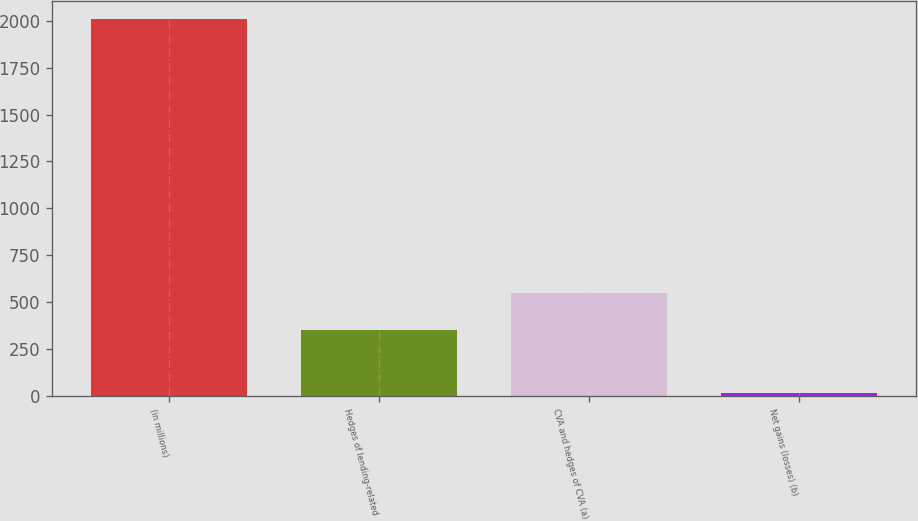Convert chart to OTSL. <chart><loc_0><loc_0><loc_500><loc_500><bar_chart><fcel>(in millions)<fcel>Hedges of lending-related<fcel>CVA and hedges of CVA (a)<fcel>Net gains (losses) (b)<nl><fcel>2007<fcel>350<fcel>549.4<fcel>13<nl></chart> 